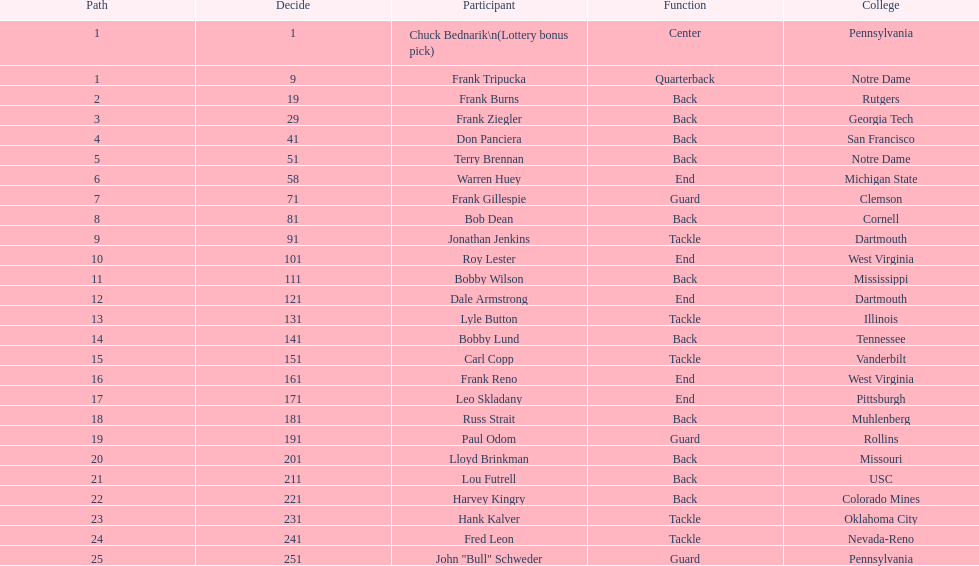Most prevalent school Pennsylvania. 